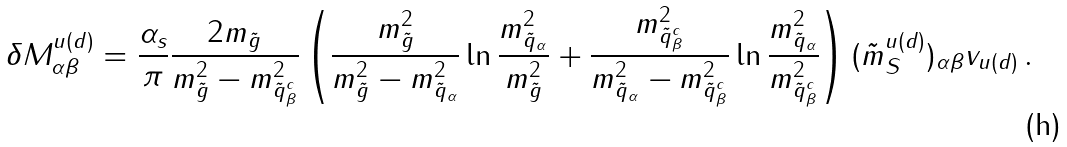Convert formula to latex. <formula><loc_0><loc_0><loc_500><loc_500>\delta M ^ { u ( d ) } _ { \alpha \beta } = \frac { \alpha _ { s } } { \pi } \frac { 2 m _ { \tilde { g } } } { m _ { \tilde { g } } ^ { 2 } - m _ { \tilde { q } ^ { c } _ { \beta } } ^ { 2 } } \left ( \frac { m _ { \tilde { g } } ^ { 2 } } { m _ { \tilde { g } } ^ { 2 } - m _ { \tilde { q } _ { \alpha } } ^ { 2 } } \ln \frac { m _ { \tilde { q } _ { \alpha } } ^ { 2 } } { m _ { \tilde { g } } ^ { 2 } } + \frac { m _ { \tilde { q } _ { \beta } ^ { c } } ^ { 2 } } { m _ { \tilde { q } _ { \alpha } } ^ { 2 } - m _ { \tilde { q } _ { \beta } ^ { c } } ^ { 2 } } \ln \frac { m _ { \tilde { q } _ { \alpha } } ^ { 2 } } { m _ { \tilde { q } _ { \beta } ^ { c } } ^ { 2 } } \right ) ( \tilde { m } _ { S } ^ { u ( d ) } ) _ { \alpha \beta } v _ { u ( d ) } \, .</formula> 